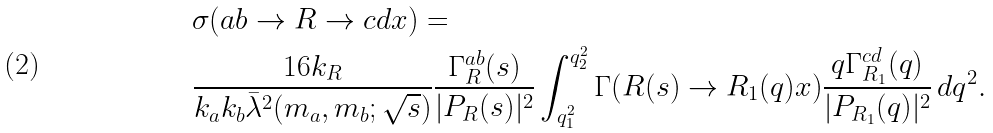Convert formula to latex. <formula><loc_0><loc_0><loc_500><loc_500>& \sigma ( a b \rightarrow R \rightarrow c d x ) = \\ & \frac { 1 6 k _ { R } } { k _ { a } k _ { b } \bar { \lambda } ^ { 2 } ( m _ { a } , m _ { b } ; \sqrt { s } ) } \frac { \Gamma ^ { a b } _ { R } ( s ) } { | P _ { R } ( s ) | ^ { 2 } } \int _ { q ^ { 2 } _ { 1 } } ^ { q ^ { 2 } _ { 2 } } \Gamma ( R ( s ) \rightarrow R _ { 1 } ( q ) x ) \frac { q \Gamma ^ { c d } _ { R _ { 1 } } ( q ) } { | P _ { R _ { 1 } } ( q ) | ^ { 2 } } \, d q ^ { 2 } .</formula> 